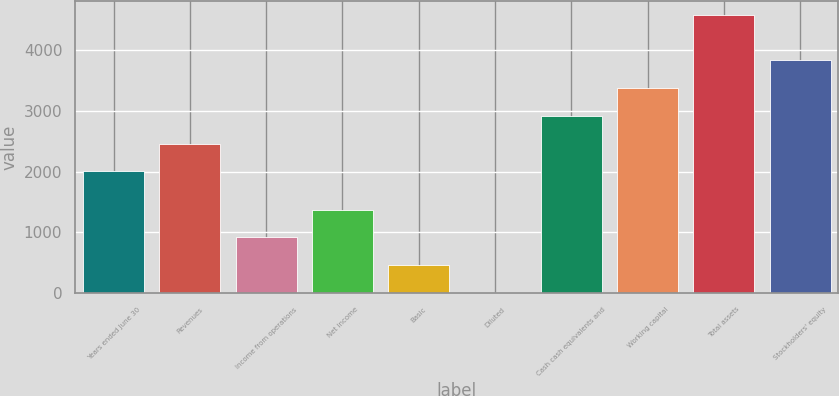Convert chart. <chart><loc_0><loc_0><loc_500><loc_500><bar_chart><fcel>Years ended June 30<fcel>Revenues<fcel>Income from operations<fcel>Net income<fcel>Basic<fcel>Diluted<fcel>Cash cash equivalents and<fcel>Working capital<fcel>Total assets<fcel>Stockholders' equity<nl><fcel>2006<fcel>2463.41<fcel>916.68<fcel>1374.09<fcel>459.27<fcel>1.86<fcel>2920.82<fcel>3378.23<fcel>4576<fcel>3835.64<nl></chart> 